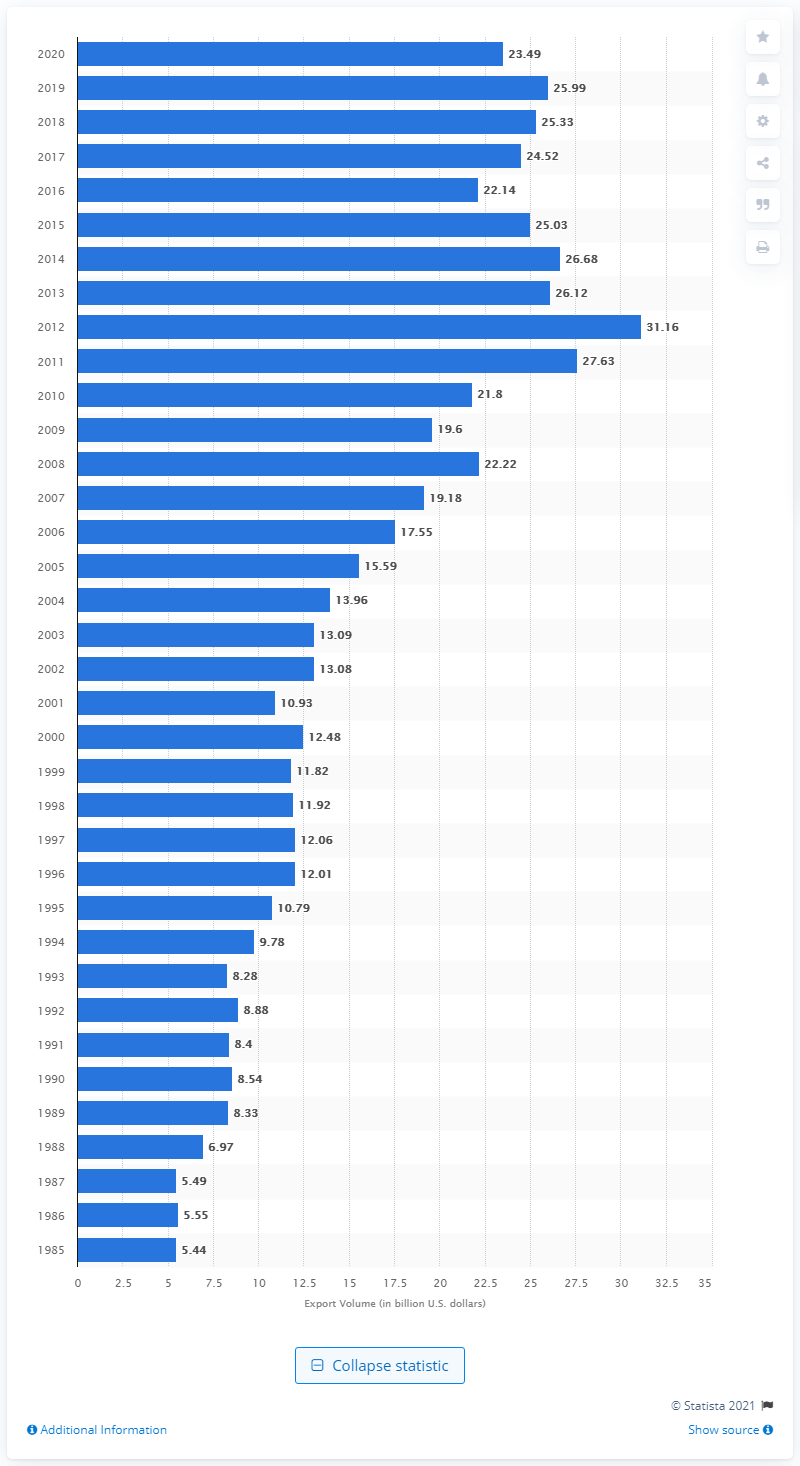Give some essential details in this illustration. In 2020, the value of exports to Australia was 23.49 billion dollars. 